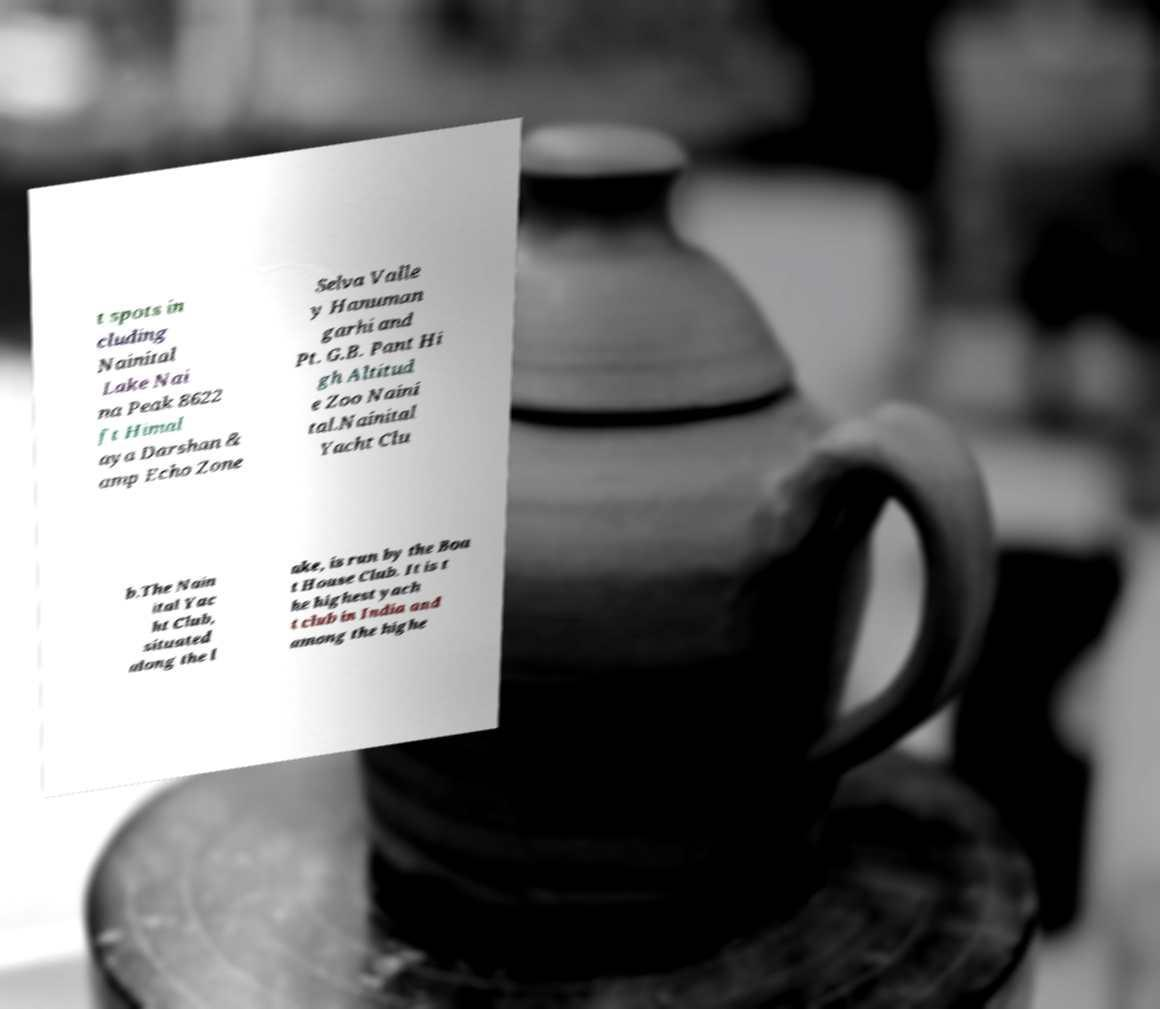I need the written content from this picture converted into text. Can you do that? t spots in cluding Nainital Lake Nai na Peak 8622 ft Himal aya Darshan & amp Echo Zone Selva Valle y Hanuman garhi and Pt. G.B. Pant Hi gh Altitud e Zoo Naini tal.Nainital Yacht Clu b.The Nain ital Yac ht Club, situated along the l ake, is run by the Boa t House Club. It is t he highest yach t club in India and among the highe 